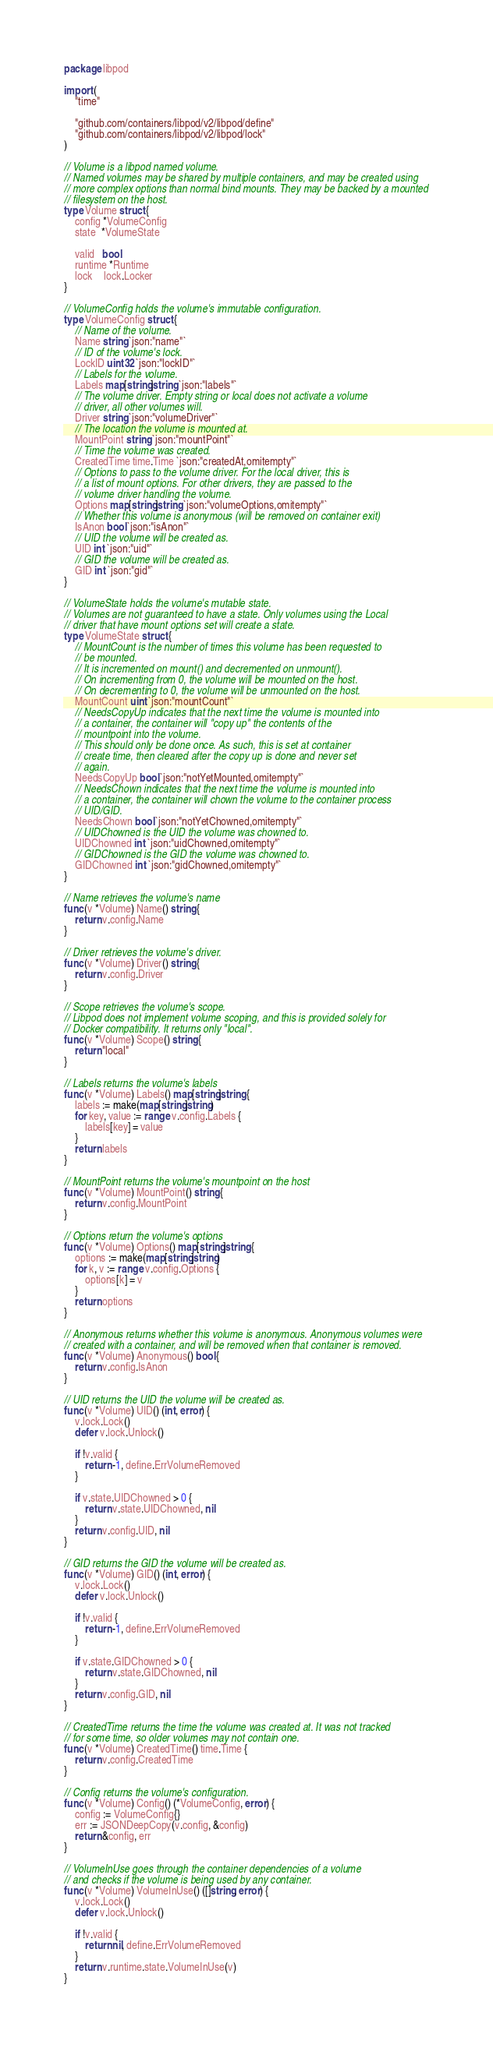Convert code to text. <code><loc_0><loc_0><loc_500><loc_500><_Go_>package libpod

import (
	"time"

	"github.com/containers/libpod/v2/libpod/define"
	"github.com/containers/libpod/v2/libpod/lock"
)

// Volume is a libpod named volume.
// Named volumes may be shared by multiple containers, and may be created using
// more complex options than normal bind mounts. They may be backed by a mounted
// filesystem on the host.
type Volume struct {
	config *VolumeConfig
	state  *VolumeState

	valid   bool
	runtime *Runtime
	lock    lock.Locker
}

// VolumeConfig holds the volume's immutable configuration.
type VolumeConfig struct {
	// Name of the volume.
	Name string `json:"name"`
	// ID of the volume's lock.
	LockID uint32 `json:"lockID"`
	// Labels for the volume.
	Labels map[string]string `json:"labels"`
	// The volume driver. Empty string or local does not activate a volume
	// driver, all other volumes will.
	Driver string `json:"volumeDriver"`
	// The location the volume is mounted at.
	MountPoint string `json:"mountPoint"`
	// Time the volume was created.
	CreatedTime time.Time `json:"createdAt,omitempty"`
	// Options to pass to the volume driver. For the local driver, this is
	// a list of mount options. For other drivers, they are passed to the
	// volume driver handling the volume.
	Options map[string]string `json:"volumeOptions,omitempty"`
	// Whether this volume is anonymous (will be removed on container exit)
	IsAnon bool `json:"isAnon"`
	// UID the volume will be created as.
	UID int `json:"uid"`
	// GID the volume will be created as.
	GID int `json:"gid"`
}

// VolumeState holds the volume's mutable state.
// Volumes are not guaranteed to have a state. Only volumes using the Local
// driver that have mount options set will create a state.
type VolumeState struct {
	// MountCount is the number of times this volume has been requested to
	// be mounted.
	// It is incremented on mount() and decremented on unmount().
	// On incrementing from 0, the volume will be mounted on the host.
	// On decrementing to 0, the volume will be unmounted on the host.
	MountCount uint `json:"mountCount"`
	// NeedsCopyUp indicates that the next time the volume is mounted into
	// a container, the container will "copy up" the contents of the
	// mountpoint into the volume.
	// This should only be done once. As such, this is set at container
	// create time, then cleared after the copy up is done and never set
	// again.
	NeedsCopyUp bool `json:"notYetMounted,omitempty"`
	// NeedsChown indicates that the next time the volume is mounted into
	// a container, the container will chown the volume to the container process
	// UID/GID.
	NeedsChown bool `json:"notYetChowned,omitempty"`
	// UIDChowned is the UID the volume was chowned to.
	UIDChowned int `json:"uidChowned,omitempty"`
	// GIDChowned is the GID the volume was chowned to.
	GIDChowned int `json:"gidChowned,omitempty"`
}

// Name retrieves the volume's name
func (v *Volume) Name() string {
	return v.config.Name
}

// Driver retrieves the volume's driver.
func (v *Volume) Driver() string {
	return v.config.Driver
}

// Scope retrieves the volume's scope.
// Libpod does not implement volume scoping, and this is provided solely for
// Docker compatibility. It returns only "local".
func (v *Volume) Scope() string {
	return "local"
}

// Labels returns the volume's labels
func (v *Volume) Labels() map[string]string {
	labels := make(map[string]string)
	for key, value := range v.config.Labels {
		labels[key] = value
	}
	return labels
}

// MountPoint returns the volume's mountpoint on the host
func (v *Volume) MountPoint() string {
	return v.config.MountPoint
}

// Options return the volume's options
func (v *Volume) Options() map[string]string {
	options := make(map[string]string)
	for k, v := range v.config.Options {
		options[k] = v
	}
	return options
}

// Anonymous returns whether this volume is anonymous. Anonymous volumes were
// created with a container, and will be removed when that container is removed.
func (v *Volume) Anonymous() bool {
	return v.config.IsAnon
}

// UID returns the UID the volume will be created as.
func (v *Volume) UID() (int, error) {
	v.lock.Lock()
	defer v.lock.Unlock()

	if !v.valid {
		return -1, define.ErrVolumeRemoved
	}

	if v.state.UIDChowned > 0 {
		return v.state.UIDChowned, nil
	}
	return v.config.UID, nil
}

// GID returns the GID the volume will be created as.
func (v *Volume) GID() (int, error) {
	v.lock.Lock()
	defer v.lock.Unlock()

	if !v.valid {
		return -1, define.ErrVolumeRemoved
	}

	if v.state.GIDChowned > 0 {
		return v.state.GIDChowned, nil
	}
	return v.config.GID, nil
}

// CreatedTime returns the time the volume was created at. It was not tracked
// for some time, so older volumes may not contain one.
func (v *Volume) CreatedTime() time.Time {
	return v.config.CreatedTime
}

// Config returns the volume's configuration.
func (v *Volume) Config() (*VolumeConfig, error) {
	config := VolumeConfig{}
	err := JSONDeepCopy(v.config, &config)
	return &config, err
}

// VolumeInUse goes through the container dependencies of a volume
// and checks if the volume is being used by any container.
func (v *Volume) VolumeInUse() ([]string, error) {
	v.lock.Lock()
	defer v.lock.Unlock()

	if !v.valid {
		return nil, define.ErrVolumeRemoved
	}
	return v.runtime.state.VolumeInUse(v)
}
</code> 